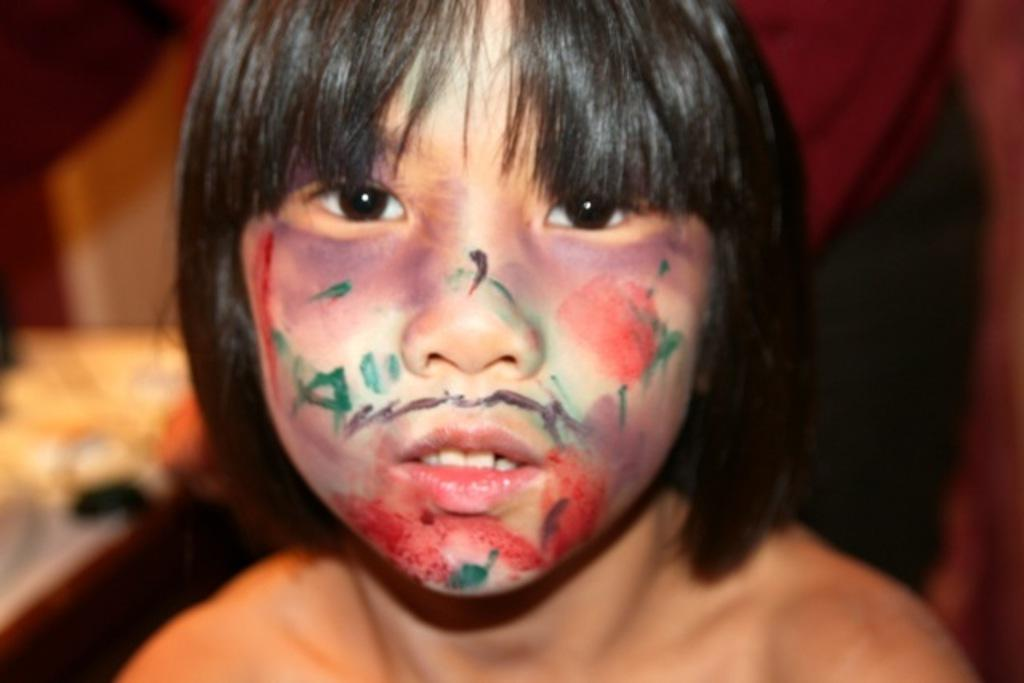What is the main subject of the image? The main subject of the image is a kid's face. Where is the kid's face located in the image? The kid's face is in the middle of the image. What type of plants can be seen growing from the kid's ears in the image? There are no plants visible in the image, and the kid's ears do not have any plants growing from them. 